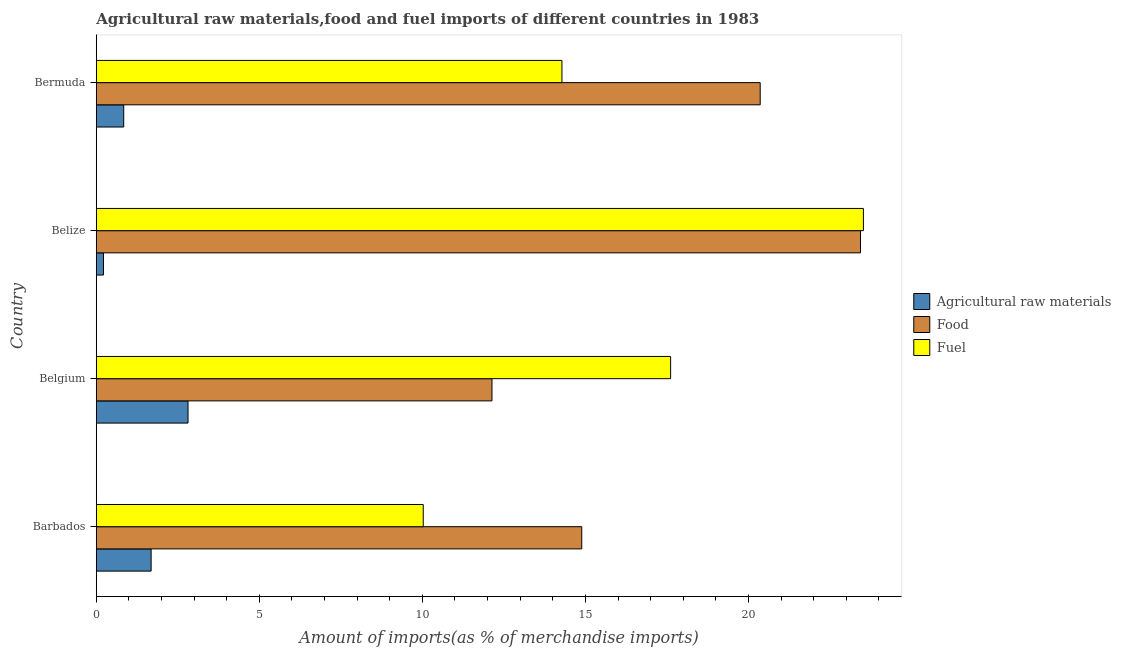How many different coloured bars are there?
Your response must be concise. 3. How many groups of bars are there?
Keep it short and to the point. 4. Are the number of bars on each tick of the Y-axis equal?
Offer a very short reply. Yes. How many bars are there on the 1st tick from the top?
Provide a short and direct response. 3. What is the label of the 4th group of bars from the top?
Ensure brevity in your answer.  Barbados. What is the percentage of raw materials imports in Barbados?
Offer a terse response. 1.68. Across all countries, what is the maximum percentage of food imports?
Offer a very short reply. 23.44. Across all countries, what is the minimum percentage of food imports?
Offer a very short reply. 12.13. In which country was the percentage of fuel imports maximum?
Offer a very short reply. Belize. In which country was the percentage of fuel imports minimum?
Offer a very short reply. Barbados. What is the total percentage of food imports in the graph?
Offer a very short reply. 70.82. What is the difference between the percentage of food imports in Belgium and that in Bermuda?
Keep it short and to the point. -8.23. What is the difference between the percentage of raw materials imports in Belgium and the percentage of fuel imports in Belize?
Offer a terse response. -20.72. What is the average percentage of fuel imports per country?
Your answer should be very brief. 16.36. What is the difference between the percentage of food imports and percentage of raw materials imports in Belgium?
Offer a terse response. 9.32. What is the ratio of the percentage of raw materials imports in Barbados to that in Belgium?
Provide a succinct answer. 0.6. Is the difference between the percentage of food imports in Belgium and Bermuda greater than the difference between the percentage of fuel imports in Belgium and Bermuda?
Provide a short and direct response. No. What is the difference between the highest and the second highest percentage of fuel imports?
Make the answer very short. 5.91. What is the difference between the highest and the lowest percentage of food imports?
Give a very brief answer. 11.3. Is the sum of the percentage of raw materials imports in Belize and Bermuda greater than the maximum percentage of fuel imports across all countries?
Ensure brevity in your answer.  No. What does the 3rd bar from the top in Belize represents?
Provide a short and direct response. Agricultural raw materials. What does the 1st bar from the bottom in Bermuda represents?
Provide a short and direct response. Agricultural raw materials. How many bars are there?
Provide a short and direct response. 12. Are all the bars in the graph horizontal?
Your answer should be very brief. Yes. What is the difference between two consecutive major ticks on the X-axis?
Give a very brief answer. 5. Does the graph contain grids?
Make the answer very short. No. Where does the legend appear in the graph?
Offer a very short reply. Center right. How many legend labels are there?
Your answer should be compact. 3. What is the title of the graph?
Ensure brevity in your answer.  Agricultural raw materials,food and fuel imports of different countries in 1983. Does "Primary" appear as one of the legend labels in the graph?
Provide a short and direct response. No. What is the label or title of the X-axis?
Keep it short and to the point. Amount of imports(as % of merchandise imports). What is the Amount of imports(as % of merchandise imports) in Agricultural raw materials in Barbados?
Your answer should be very brief. 1.68. What is the Amount of imports(as % of merchandise imports) of Food in Barbados?
Keep it short and to the point. 14.89. What is the Amount of imports(as % of merchandise imports) of Fuel in Barbados?
Offer a very short reply. 10.03. What is the Amount of imports(as % of merchandise imports) in Agricultural raw materials in Belgium?
Provide a succinct answer. 2.81. What is the Amount of imports(as % of merchandise imports) in Food in Belgium?
Ensure brevity in your answer.  12.13. What is the Amount of imports(as % of merchandise imports) of Fuel in Belgium?
Ensure brevity in your answer.  17.61. What is the Amount of imports(as % of merchandise imports) of Agricultural raw materials in Belize?
Ensure brevity in your answer.  0.22. What is the Amount of imports(as % of merchandise imports) in Food in Belize?
Keep it short and to the point. 23.44. What is the Amount of imports(as % of merchandise imports) of Fuel in Belize?
Ensure brevity in your answer.  23.53. What is the Amount of imports(as % of merchandise imports) of Agricultural raw materials in Bermuda?
Offer a terse response. 0.84. What is the Amount of imports(as % of merchandise imports) of Food in Bermuda?
Your answer should be compact. 20.36. What is the Amount of imports(as % of merchandise imports) in Fuel in Bermuda?
Your response must be concise. 14.28. Across all countries, what is the maximum Amount of imports(as % of merchandise imports) of Agricultural raw materials?
Give a very brief answer. 2.81. Across all countries, what is the maximum Amount of imports(as % of merchandise imports) of Food?
Ensure brevity in your answer.  23.44. Across all countries, what is the maximum Amount of imports(as % of merchandise imports) of Fuel?
Offer a terse response. 23.53. Across all countries, what is the minimum Amount of imports(as % of merchandise imports) of Agricultural raw materials?
Ensure brevity in your answer.  0.22. Across all countries, what is the minimum Amount of imports(as % of merchandise imports) in Food?
Your answer should be compact. 12.13. Across all countries, what is the minimum Amount of imports(as % of merchandise imports) in Fuel?
Provide a succinct answer. 10.03. What is the total Amount of imports(as % of merchandise imports) of Agricultural raw materials in the graph?
Make the answer very short. 5.55. What is the total Amount of imports(as % of merchandise imports) of Food in the graph?
Provide a succinct answer. 70.82. What is the total Amount of imports(as % of merchandise imports) in Fuel in the graph?
Ensure brevity in your answer.  65.45. What is the difference between the Amount of imports(as % of merchandise imports) in Agricultural raw materials in Barbados and that in Belgium?
Your answer should be compact. -1.13. What is the difference between the Amount of imports(as % of merchandise imports) in Food in Barbados and that in Belgium?
Provide a short and direct response. 2.75. What is the difference between the Amount of imports(as % of merchandise imports) of Fuel in Barbados and that in Belgium?
Ensure brevity in your answer.  -7.59. What is the difference between the Amount of imports(as % of merchandise imports) of Agricultural raw materials in Barbados and that in Belize?
Give a very brief answer. 1.46. What is the difference between the Amount of imports(as % of merchandise imports) of Food in Barbados and that in Belize?
Keep it short and to the point. -8.55. What is the difference between the Amount of imports(as % of merchandise imports) of Fuel in Barbados and that in Belize?
Provide a succinct answer. -13.5. What is the difference between the Amount of imports(as % of merchandise imports) of Agricultural raw materials in Barbados and that in Bermuda?
Your answer should be compact. 0.84. What is the difference between the Amount of imports(as % of merchandise imports) of Food in Barbados and that in Bermuda?
Ensure brevity in your answer.  -5.47. What is the difference between the Amount of imports(as % of merchandise imports) in Fuel in Barbados and that in Bermuda?
Your answer should be very brief. -4.25. What is the difference between the Amount of imports(as % of merchandise imports) in Agricultural raw materials in Belgium and that in Belize?
Offer a very short reply. 2.59. What is the difference between the Amount of imports(as % of merchandise imports) of Food in Belgium and that in Belize?
Provide a succinct answer. -11.3. What is the difference between the Amount of imports(as % of merchandise imports) of Fuel in Belgium and that in Belize?
Provide a short and direct response. -5.91. What is the difference between the Amount of imports(as % of merchandise imports) in Agricultural raw materials in Belgium and that in Bermuda?
Your answer should be compact. 1.97. What is the difference between the Amount of imports(as % of merchandise imports) in Food in Belgium and that in Bermuda?
Provide a short and direct response. -8.23. What is the difference between the Amount of imports(as % of merchandise imports) in Fuel in Belgium and that in Bermuda?
Provide a succinct answer. 3.33. What is the difference between the Amount of imports(as % of merchandise imports) of Agricultural raw materials in Belize and that in Bermuda?
Offer a very short reply. -0.62. What is the difference between the Amount of imports(as % of merchandise imports) in Food in Belize and that in Bermuda?
Your answer should be very brief. 3.08. What is the difference between the Amount of imports(as % of merchandise imports) in Fuel in Belize and that in Bermuda?
Keep it short and to the point. 9.25. What is the difference between the Amount of imports(as % of merchandise imports) of Agricultural raw materials in Barbados and the Amount of imports(as % of merchandise imports) of Food in Belgium?
Keep it short and to the point. -10.45. What is the difference between the Amount of imports(as % of merchandise imports) of Agricultural raw materials in Barbados and the Amount of imports(as % of merchandise imports) of Fuel in Belgium?
Offer a very short reply. -15.93. What is the difference between the Amount of imports(as % of merchandise imports) of Food in Barbados and the Amount of imports(as % of merchandise imports) of Fuel in Belgium?
Ensure brevity in your answer.  -2.73. What is the difference between the Amount of imports(as % of merchandise imports) in Agricultural raw materials in Barbados and the Amount of imports(as % of merchandise imports) in Food in Belize?
Make the answer very short. -21.76. What is the difference between the Amount of imports(as % of merchandise imports) in Agricultural raw materials in Barbados and the Amount of imports(as % of merchandise imports) in Fuel in Belize?
Offer a terse response. -21.85. What is the difference between the Amount of imports(as % of merchandise imports) in Food in Barbados and the Amount of imports(as % of merchandise imports) in Fuel in Belize?
Give a very brief answer. -8.64. What is the difference between the Amount of imports(as % of merchandise imports) of Agricultural raw materials in Barbados and the Amount of imports(as % of merchandise imports) of Food in Bermuda?
Make the answer very short. -18.68. What is the difference between the Amount of imports(as % of merchandise imports) in Agricultural raw materials in Barbados and the Amount of imports(as % of merchandise imports) in Fuel in Bermuda?
Offer a very short reply. -12.6. What is the difference between the Amount of imports(as % of merchandise imports) in Food in Barbados and the Amount of imports(as % of merchandise imports) in Fuel in Bermuda?
Keep it short and to the point. 0.61. What is the difference between the Amount of imports(as % of merchandise imports) of Agricultural raw materials in Belgium and the Amount of imports(as % of merchandise imports) of Food in Belize?
Keep it short and to the point. -20.63. What is the difference between the Amount of imports(as % of merchandise imports) in Agricultural raw materials in Belgium and the Amount of imports(as % of merchandise imports) in Fuel in Belize?
Provide a short and direct response. -20.71. What is the difference between the Amount of imports(as % of merchandise imports) in Food in Belgium and the Amount of imports(as % of merchandise imports) in Fuel in Belize?
Provide a short and direct response. -11.39. What is the difference between the Amount of imports(as % of merchandise imports) in Agricultural raw materials in Belgium and the Amount of imports(as % of merchandise imports) in Food in Bermuda?
Give a very brief answer. -17.55. What is the difference between the Amount of imports(as % of merchandise imports) of Agricultural raw materials in Belgium and the Amount of imports(as % of merchandise imports) of Fuel in Bermuda?
Your answer should be very brief. -11.47. What is the difference between the Amount of imports(as % of merchandise imports) in Food in Belgium and the Amount of imports(as % of merchandise imports) in Fuel in Bermuda?
Offer a terse response. -2.15. What is the difference between the Amount of imports(as % of merchandise imports) in Agricultural raw materials in Belize and the Amount of imports(as % of merchandise imports) in Food in Bermuda?
Make the answer very short. -20.14. What is the difference between the Amount of imports(as % of merchandise imports) in Agricultural raw materials in Belize and the Amount of imports(as % of merchandise imports) in Fuel in Bermuda?
Make the answer very short. -14.06. What is the difference between the Amount of imports(as % of merchandise imports) of Food in Belize and the Amount of imports(as % of merchandise imports) of Fuel in Bermuda?
Give a very brief answer. 9.16. What is the average Amount of imports(as % of merchandise imports) in Agricultural raw materials per country?
Give a very brief answer. 1.39. What is the average Amount of imports(as % of merchandise imports) of Food per country?
Provide a short and direct response. 17.71. What is the average Amount of imports(as % of merchandise imports) in Fuel per country?
Ensure brevity in your answer.  16.36. What is the difference between the Amount of imports(as % of merchandise imports) of Agricultural raw materials and Amount of imports(as % of merchandise imports) of Food in Barbados?
Offer a terse response. -13.21. What is the difference between the Amount of imports(as % of merchandise imports) of Agricultural raw materials and Amount of imports(as % of merchandise imports) of Fuel in Barbados?
Your response must be concise. -8.35. What is the difference between the Amount of imports(as % of merchandise imports) in Food and Amount of imports(as % of merchandise imports) in Fuel in Barbados?
Your response must be concise. 4.86. What is the difference between the Amount of imports(as % of merchandise imports) of Agricultural raw materials and Amount of imports(as % of merchandise imports) of Food in Belgium?
Keep it short and to the point. -9.32. What is the difference between the Amount of imports(as % of merchandise imports) in Agricultural raw materials and Amount of imports(as % of merchandise imports) in Fuel in Belgium?
Keep it short and to the point. -14.8. What is the difference between the Amount of imports(as % of merchandise imports) of Food and Amount of imports(as % of merchandise imports) of Fuel in Belgium?
Give a very brief answer. -5.48. What is the difference between the Amount of imports(as % of merchandise imports) in Agricultural raw materials and Amount of imports(as % of merchandise imports) in Food in Belize?
Keep it short and to the point. -23.22. What is the difference between the Amount of imports(as % of merchandise imports) of Agricultural raw materials and Amount of imports(as % of merchandise imports) of Fuel in Belize?
Provide a succinct answer. -23.31. What is the difference between the Amount of imports(as % of merchandise imports) of Food and Amount of imports(as % of merchandise imports) of Fuel in Belize?
Provide a short and direct response. -0.09. What is the difference between the Amount of imports(as % of merchandise imports) of Agricultural raw materials and Amount of imports(as % of merchandise imports) of Food in Bermuda?
Your response must be concise. -19.52. What is the difference between the Amount of imports(as % of merchandise imports) of Agricultural raw materials and Amount of imports(as % of merchandise imports) of Fuel in Bermuda?
Provide a succinct answer. -13.44. What is the difference between the Amount of imports(as % of merchandise imports) of Food and Amount of imports(as % of merchandise imports) of Fuel in Bermuda?
Offer a very short reply. 6.08. What is the ratio of the Amount of imports(as % of merchandise imports) of Agricultural raw materials in Barbados to that in Belgium?
Offer a terse response. 0.6. What is the ratio of the Amount of imports(as % of merchandise imports) of Food in Barbados to that in Belgium?
Ensure brevity in your answer.  1.23. What is the ratio of the Amount of imports(as % of merchandise imports) of Fuel in Barbados to that in Belgium?
Your response must be concise. 0.57. What is the ratio of the Amount of imports(as % of merchandise imports) of Agricultural raw materials in Barbados to that in Belize?
Offer a very short reply. 7.7. What is the ratio of the Amount of imports(as % of merchandise imports) in Food in Barbados to that in Belize?
Give a very brief answer. 0.64. What is the ratio of the Amount of imports(as % of merchandise imports) in Fuel in Barbados to that in Belize?
Keep it short and to the point. 0.43. What is the ratio of the Amount of imports(as % of merchandise imports) in Agricultural raw materials in Barbados to that in Bermuda?
Make the answer very short. 2. What is the ratio of the Amount of imports(as % of merchandise imports) of Food in Barbados to that in Bermuda?
Offer a very short reply. 0.73. What is the ratio of the Amount of imports(as % of merchandise imports) in Fuel in Barbados to that in Bermuda?
Your answer should be compact. 0.7. What is the ratio of the Amount of imports(as % of merchandise imports) of Agricultural raw materials in Belgium to that in Belize?
Make the answer very short. 12.88. What is the ratio of the Amount of imports(as % of merchandise imports) in Food in Belgium to that in Belize?
Give a very brief answer. 0.52. What is the ratio of the Amount of imports(as % of merchandise imports) in Fuel in Belgium to that in Belize?
Offer a very short reply. 0.75. What is the ratio of the Amount of imports(as % of merchandise imports) of Agricultural raw materials in Belgium to that in Bermuda?
Give a very brief answer. 3.35. What is the ratio of the Amount of imports(as % of merchandise imports) in Food in Belgium to that in Bermuda?
Ensure brevity in your answer.  0.6. What is the ratio of the Amount of imports(as % of merchandise imports) of Fuel in Belgium to that in Bermuda?
Your answer should be very brief. 1.23. What is the ratio of the Amount of imports(as % of merchandise imports) in Agricultural raw materials in Belize to that in Bermuda?
Keep it short and to the point. 0.26. What is the ratio of the Amount of imports(as % of merchandise imports) of Food in Belize to that in Bermuda?
Give a very brief answer. 1.15. What is the ratio of the Amount of imports(as % of merchandise imports) in Fuel in Belize to that in Bermuda?
Offer a terse response. 1.65. What is the difference between the highest and the second highest Amount of imports(as % of merchandise imports) in Agricultural raw materials?
Your response must be concise. 1.13. What is the difference between the highest and the second highest Amount of imports(as % of merchandise imports) of Food?
Provide a short and direct response. 3.08. What is the difference between the highest and the second highest Amount of imports(as % of merchandise imports) of Fuel?
Provide a short and direct response. 5.91. What is the difference between the highest and the lowest Amount of imports(as % of merchandise imports) of Agricultural raw materials?
Offer a very short reply. 2.59. What is the difference between the highest and the lowest Amount of imports(as % of merchandise imports) of Food?
Ensure brevity in your answer.  11.3. What is the difference between the highest and the lowest Amount of imports(as % of merchandise imports) of Fuel?
Make the answer very short. 13.5. 